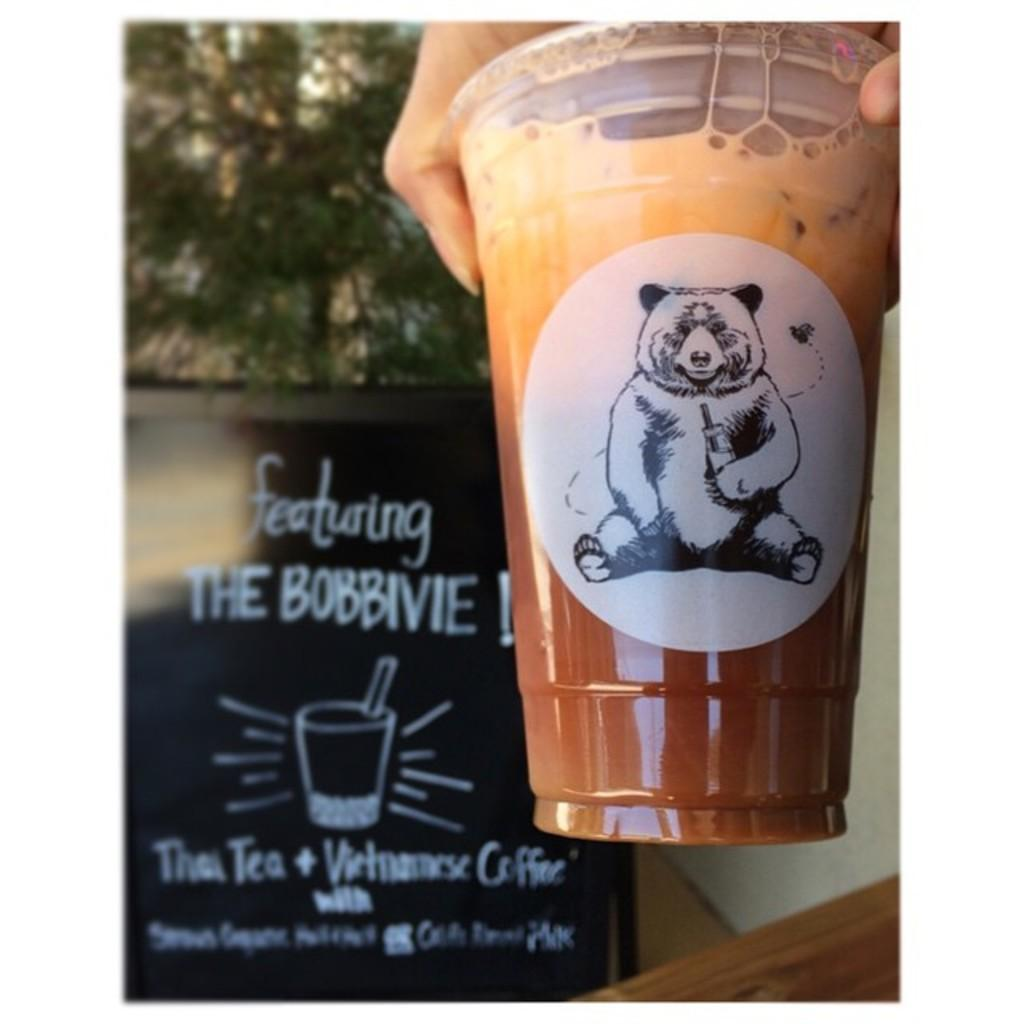What is being held by the person's hand in the image? There is a person's hand holding a cup in the image. What can be seen in the background of the image? There is a board and a tree in the background of the image. What type of fang can be seen in the image? There is no fang present in the image. How does the person's sister interact with the cup in the image? There is no mention of a sister in the image, so it is not possible to answer how they might interact with the cup. 